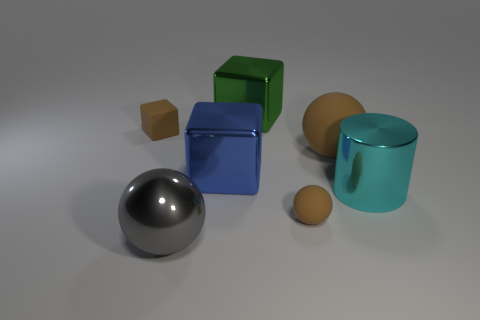Add 3 tiny blue objects. How many objects exist? 10 Subtract all cylinders. How many objects are left? 6 Add 1 cylinders. How many cylinders exist? 2 Subtract 0 gray cubes. How many objects are left? 7 Subtract all tiny cyan matte objects. Subtract all brown rubber cubes. How many objects are left? 6 Add 2 blue cubes. How many blue cubes are left? 3 